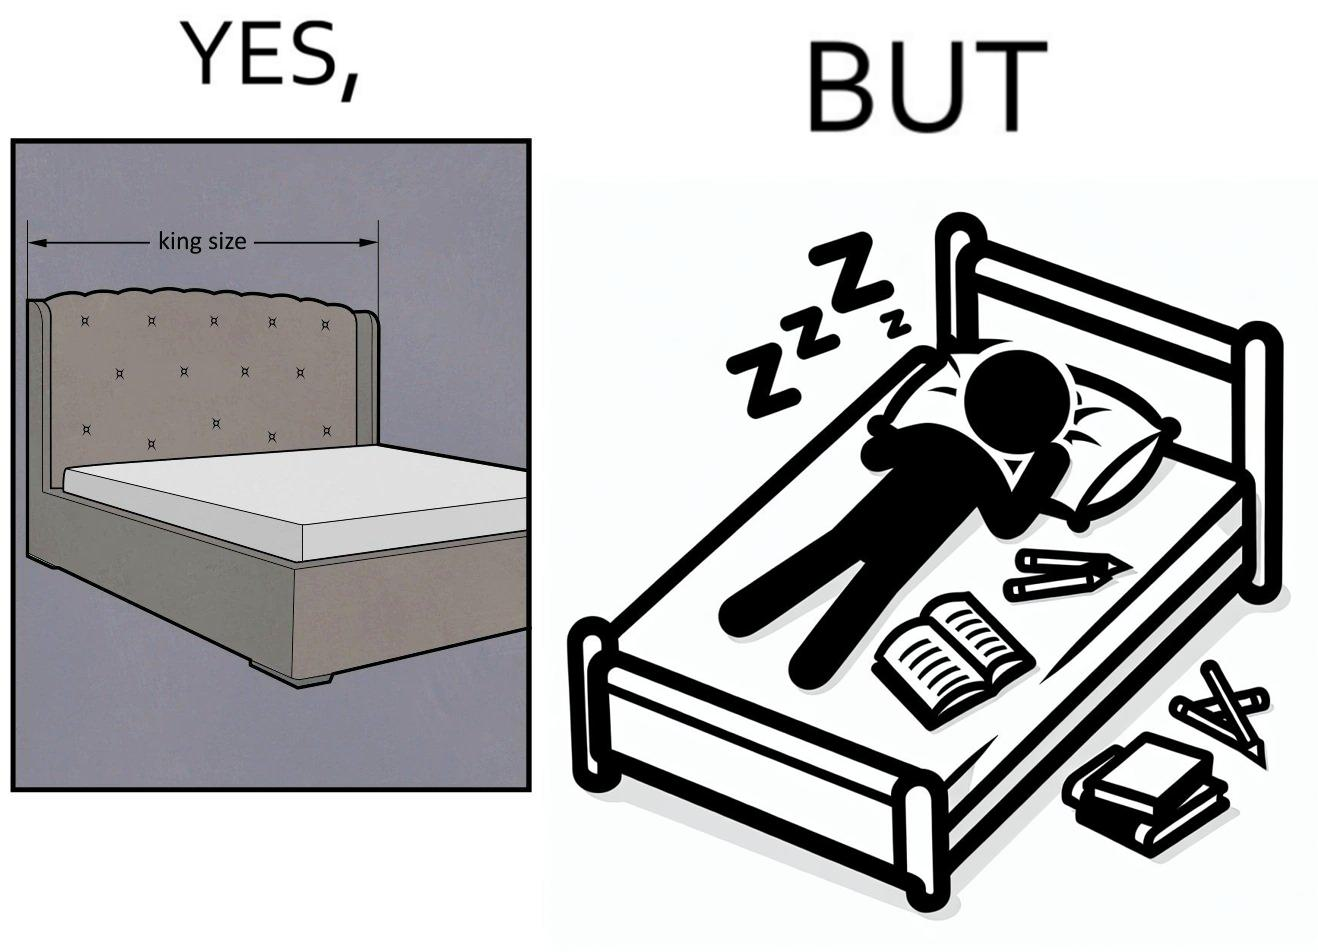Describe what you see in the left and right parts of this image. In the left part of the image: There is a bed of king size. In the right part of the image: There is a person sleeping with his material on its bed; 